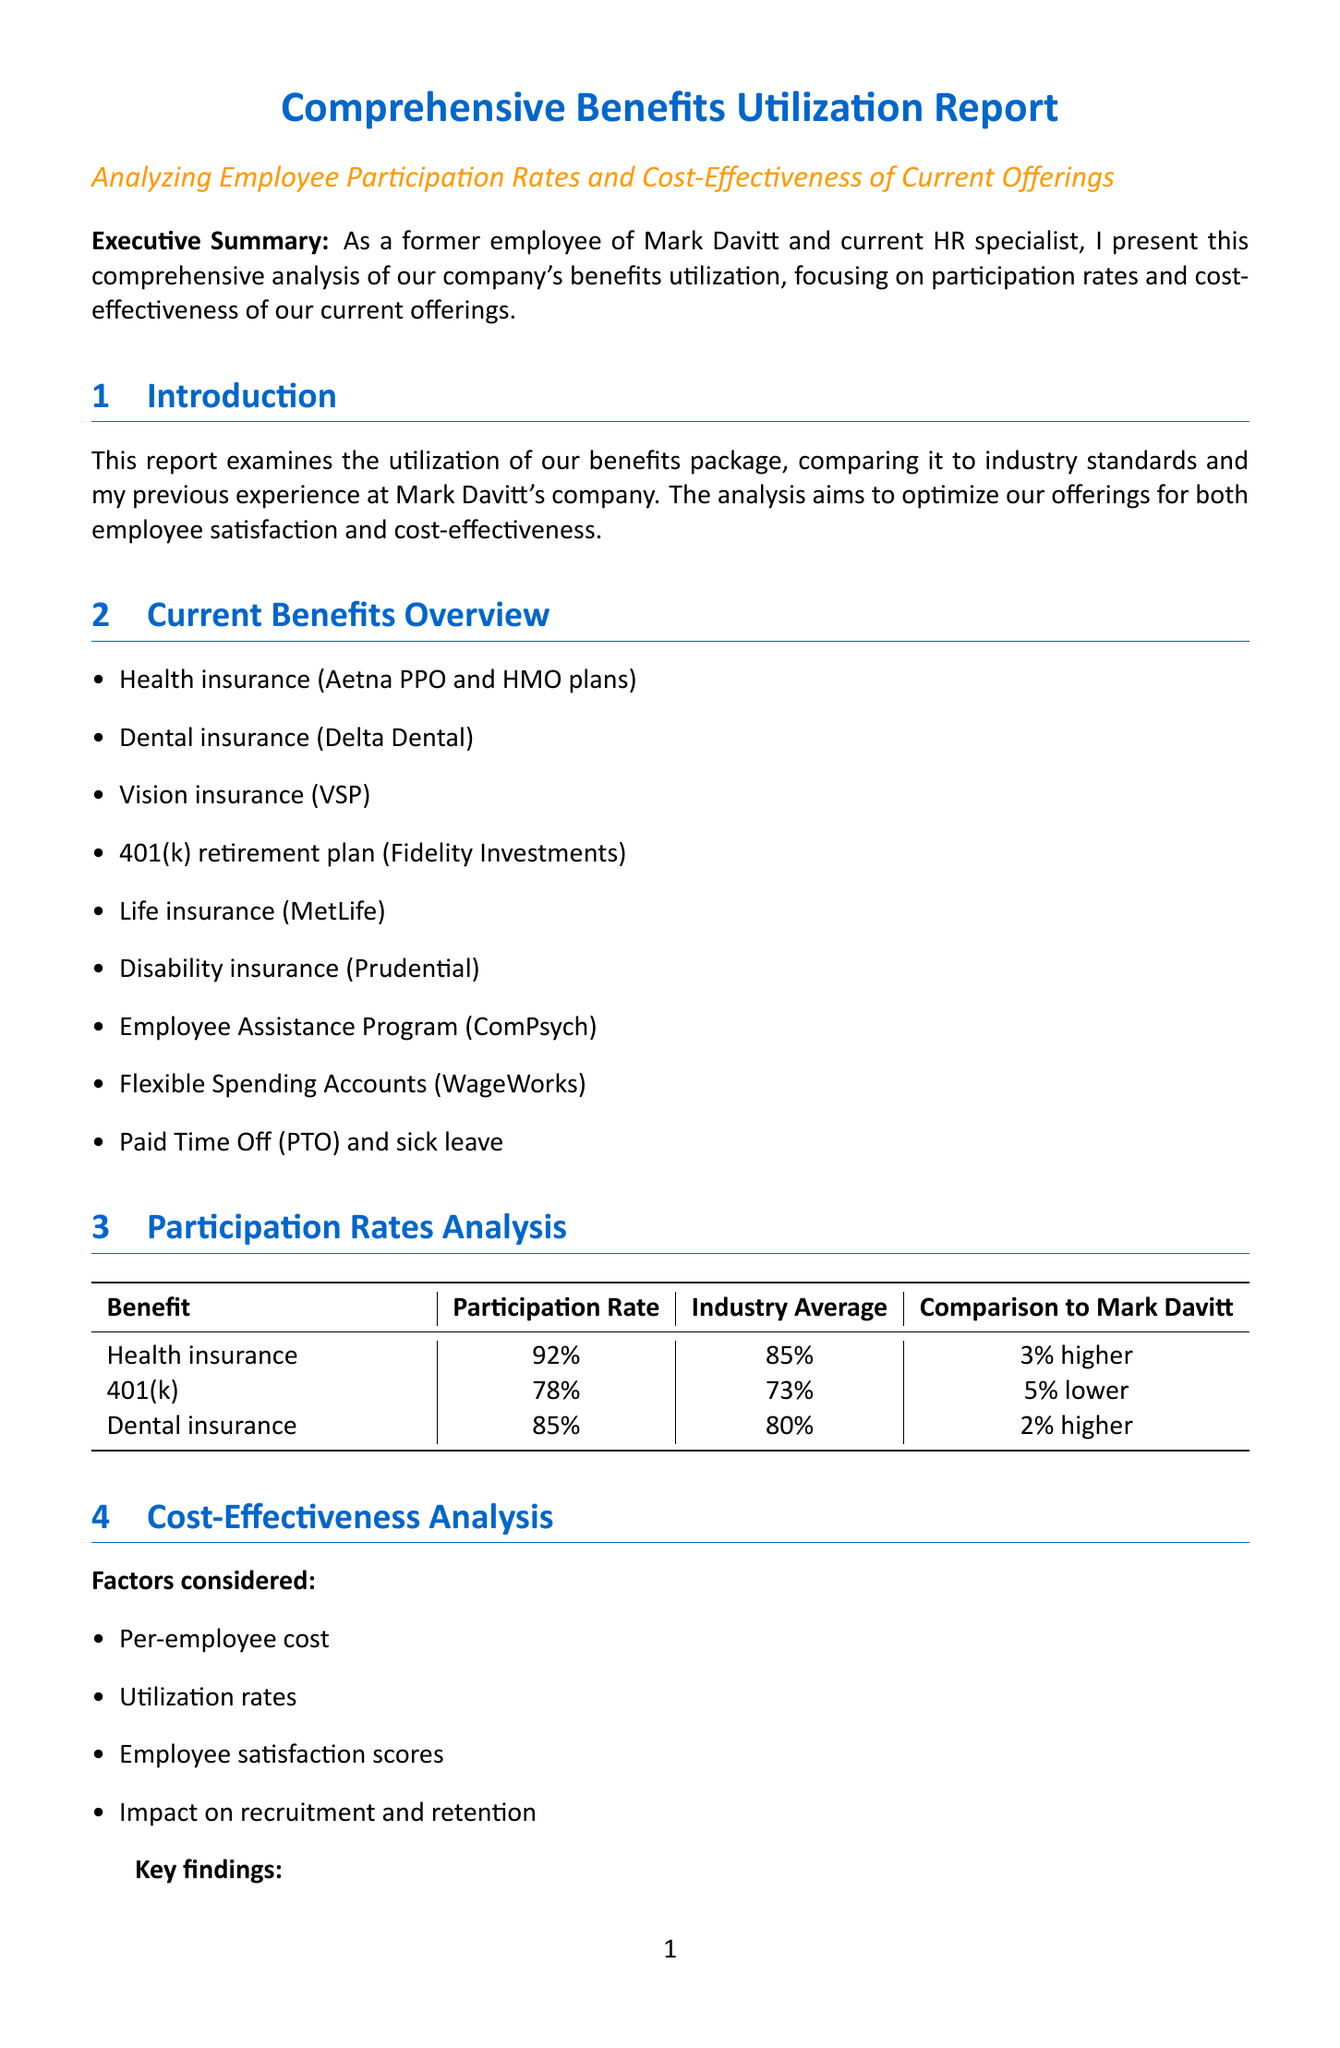What is the participation rate for health insurance? The participation rate for health insurance is provided in the Participation Rates Analysis section of the document.
Answer: 92% What company provides the dental insurance? The company providing dental insurance is listed in the Current Benefits Overview section.
Answer: Delta Dental What is the key finding regarding the EAP program? The key finding regarding the EAP program is mentioned in the Cost-Effectiveness Analysis section.
Answer: Low utilization (15%) What does the current company offer for retirement benefits compared to Mark Davitt's company? The comparison of retirement benefits is found in the Benchmarking Against Mark Davitt's Company section.
Answer: 4% 401(k) match What recommendation is made to improve the retirement match? The recommendations for improving the retirement match are detailed in the Recommendations section of the document.
Answer: Enhance 401(k) match to 5% What method was used to gather employee feedback? The methods used to gather feedback are outlined in the Employee Feedback section.
Answer: Annual benefits survey How many PTO days does the current company offer? The number of PTO days offered by the current company is stated in the Benchmarking Against Mark Davitt's Company section.
Answer: 20 PTO days What is the focus of the executive summary? The focus of the executive summary is explained at the beginning of the document.
Answer: Comprehensive analysis of benefits utilization 